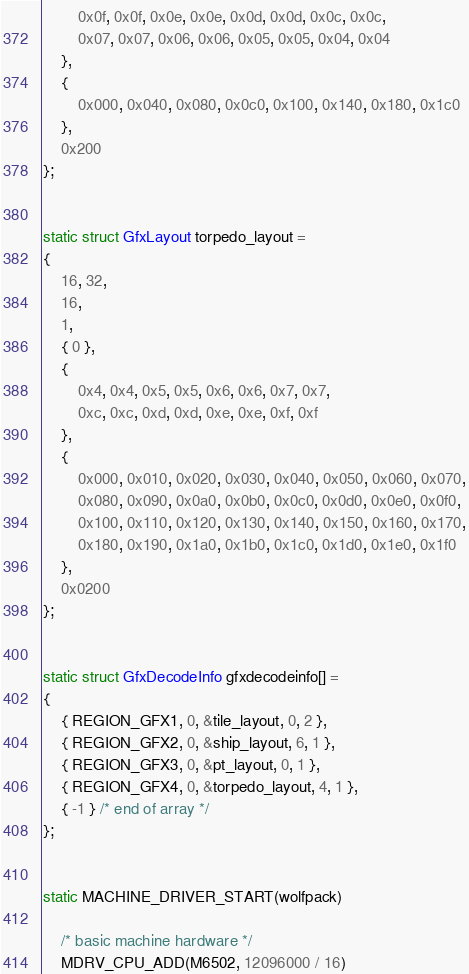<code> <loc_0><loc_0><loc_500><loc_500><_C_>		0x0f, 0x0f, 0x0e, 0x0e, 0x0d, 0x0d, 0x0c, 0x0c,
		0x07, 0x07, 0x06, 0x06, 0x05, 0x05, 0x04, 0x04
	},
	{
		0x000, 0x040, 0x080, 0x0c0, 0x100, 0x140, 0x180, 0x1c0
	},
	0x200
};


static struct GfxLayout torpedo_layout =
{
	16, 32,
	16,
	1,
	{ 0 },
	{
		0x4, 0x4, 0x5, 0x5, 0x6, 0x6, 0x7, 0x7,
		0xc, 0xc, 0xd, 0xd, 0xe, 0xe, 0xf, 0xf
	},
	{
		0x000, 0x010, 0x020, 0x030, 0x040, 0x050, 0x060, 0x070,
		0x080, 0x090, 0x0a0, 0x0b0, 0x0c0, 0x0d0, 0x0e0, 0x0f0,
		0x100, 0x110, 0x120, 0x130, 0x140, 0x150, 0x160, 0x170,
		0x180, 0x190, 0x1a0, 0x1b0, 0x1c0, 0x1d0, 0x1e0, 0x1f0
	},
	0x0200
};


static struct GfxDecodeInfo gfxdecodeinfo[] =
{
	{ REGION_GFX1, 0, &tile_layout, 0, 2 },
	{ REGION_GFX2, 0, &ship_layout, 6, 1 },
	{ REGION_GFX3, 0, &pt_layout, 0, 1 },
	{ REGION_GFX4, 0, &torpedo_layout, 4, 1 },
	{ -1 } /* end of array */
};


static MACHINE_DRIVER_START(wolfpack)

	/* basic machine hardware */
	MDRV_CPU_ADD(M6502, 12096000 / 16)</code> 